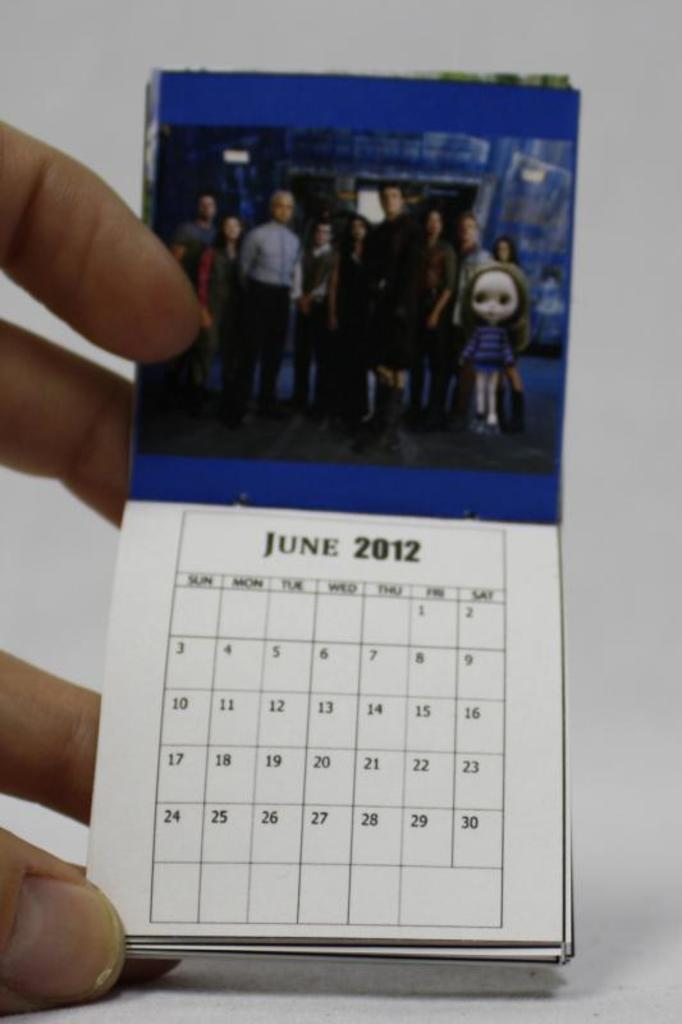What can be seen in the image involving people? There are people standing in the image. What else is present in the image besides people? Papers are visible in the image. Can you describe any specific body part that is visible in the image? A human hand is visible in the image. How does the person in the image adjust their cough? There is no mention of a cough in the image, so it cannot be determined if anyone is adjusting their cough. 